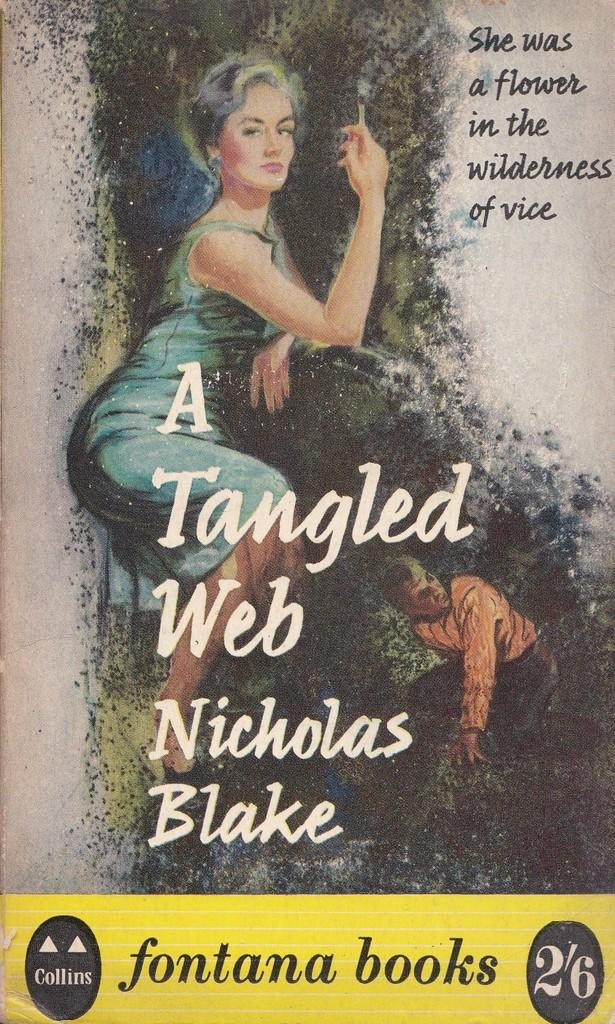Provide a one-sentence caption for the provided image. a book that is called A Tangled Web with a photo on it. 